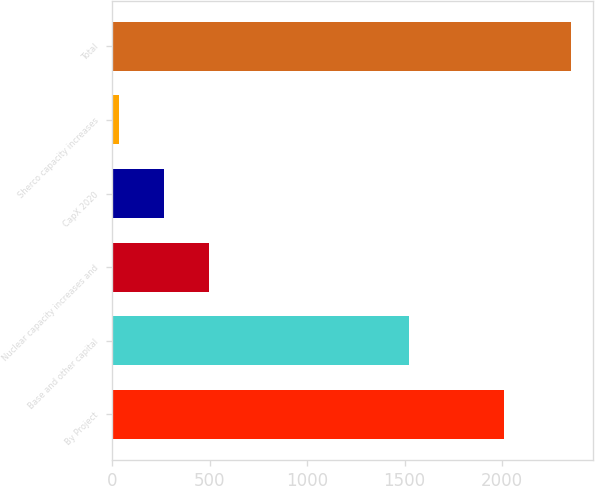Convert chart. <chart><loc_0><loc_0><loc_500><loc_500><bar_chart><fcel>By Project<fcel>Base and other capital<fcel>Nuclear capacity increases and<fcel>CapX 2020<fcel>Sherco capacity increases<fcel>Total<nl><fcel>2011<fcel>1520<fcel>498<fcel>266.5<fcel>35<fcel>2350<nl></chart> 